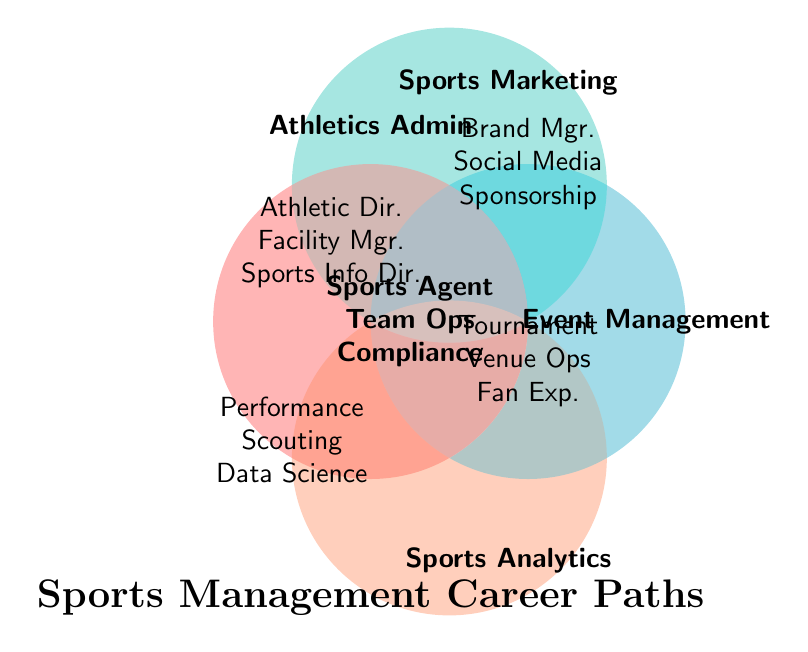What is the title of the Venn diagram? The title is written at the bottom center of the Venn diagram.
Answer: Sports Management Career Paths Which category includes the career paths of Athletic Director, Facility Manager, and Sports Information Director? These career paths are listed within the circle labeled "Athletics Admin" at the top left of the Venn diagram.
Answer: Athletics Admin What career paths do Brand Manager, Social Media Coordinator, and Sponsorship Sales fall under? These career paths are listed within the circle labeled "Sports Marketing" at the top right of the Venn diagram.
Answer: Sports Marketing Which career paths are common to all categories? The common career paths are placed at the intersection of all four circles in the center of the Venn diagram.
Answer: Sports Agent, Team Operations Manager, Compliance Officer Which category includes the career path of Performance Analyst? This career path is listed within the circle labeled "Sports Analytics" at the bottom right of the Venn diagram.
Answer: Sports Analytics How many career paths are listed under Event Management? Count the career paths listed within the circle labeled "Event Management" at the bottom left of the Venn diagram.
Answer: 3 What career paths are in Athletics Admin but not in Event Management? Compare the career paths listed under "Athletics Admin" and "Event Management".
Answer: Athletic Director, Facility Manager, Sports Information Director Which categories overlap with the career path of Social Media Coordinator? Identify the circle that contains Social Media Coordinator and note the other categories it overlaps with.
Answer: Sports Marketing overlaps partially with Athletics Admin and Event Management but not with Sports Analytics If you exclude career paths in all categories, how many unique career paths remain under Sports Analytics? Count the career paths in "Sports Analytics" excluding those listed in the center overlap.
Answer: 3 Which career path does not belong to Sports Analytics but is shared by all other categories? Look for the common career paths listed in the center that are not part of Sports Analytics.
Answer: None 